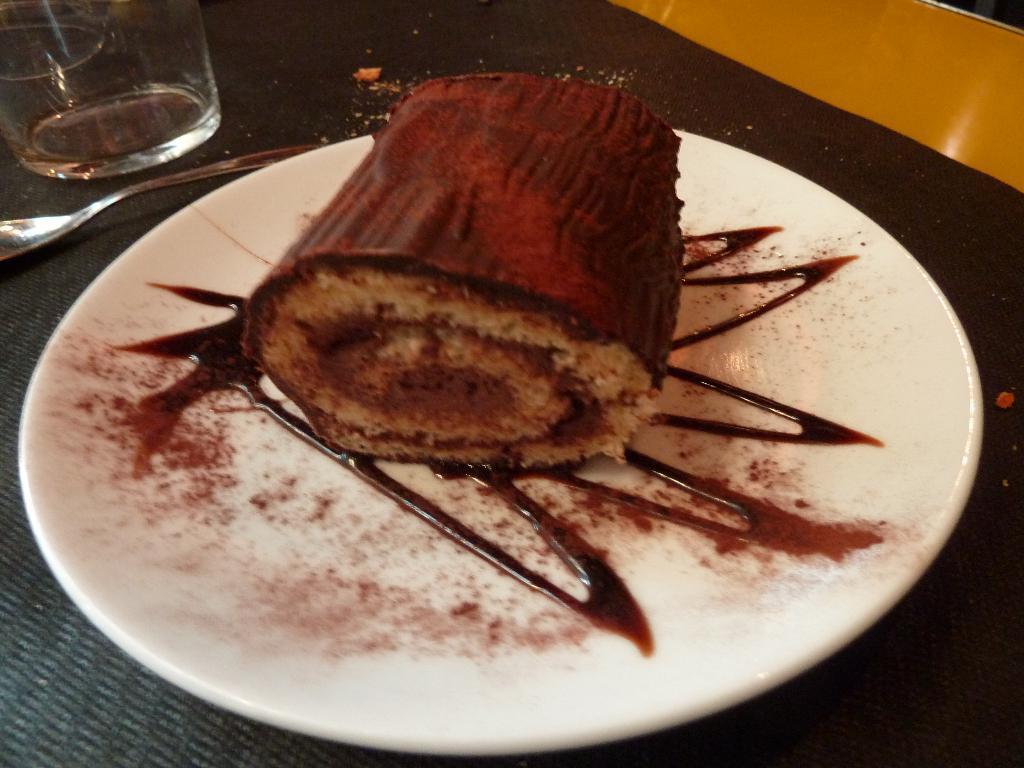Could you give a brief overview of what you see in this image? In this picture we can see a plate with food on it, glass, spoon and these all are placed on the platform. 